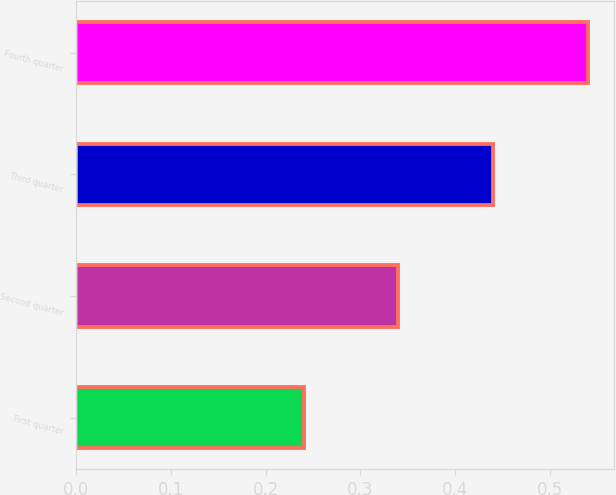Convert chart to OTSL. <chart><loc_0><loc_0><loc_500><loc_500><bar_chart><fcel>First quarter<fcel>Second quarter<fcel>Third quarter<fcel>Fourth quarter<nl><fcel>0.24<fcel>0.34<fcel>0.44<fcel>0.54<nl></chart> 